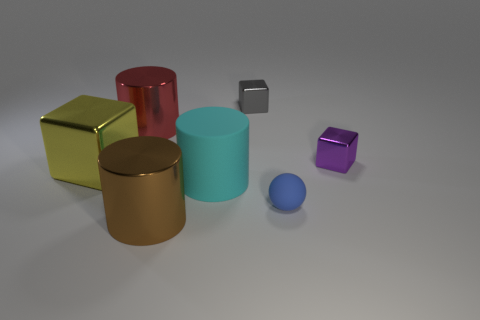There is a block that is right of the small matte object; is its size the same as the matte thing to the right of the tiny gray cube?
Ensure brevity in your answer.  Yes. There is a large cylinder behind the small cube that is in front of the gray block; what is its material?
Offer a very short reply. Metal. Are there fewer large metal things that are to the left of the red shiny thing than blocks to the left of the small blue rubber sphere?
Provide a succinct answer. Yes. Is there any other thing that is the same shape as the small rubber thing?
Ensure brevity in your answer.  No. What material is the cylinder that is behind the big cube?
Provide a short and direct response. Metal. Are there any large things in front of the small sphere?
Your response must be concise. Yes. What is the shape of the tiny blue matte object?
Your answer should be very brief. Sphere. How many things are metal things that are behind the large red object or small gray blocks?
Keep it short and to the point. 1. What number of other objects are there of the same color as the big rubber cylinder?
Make the answer very short. 0. There is another tiny shiny thing that is the same shape as the purple shiny object; what color is it?
Make the answer very short. Gray. 